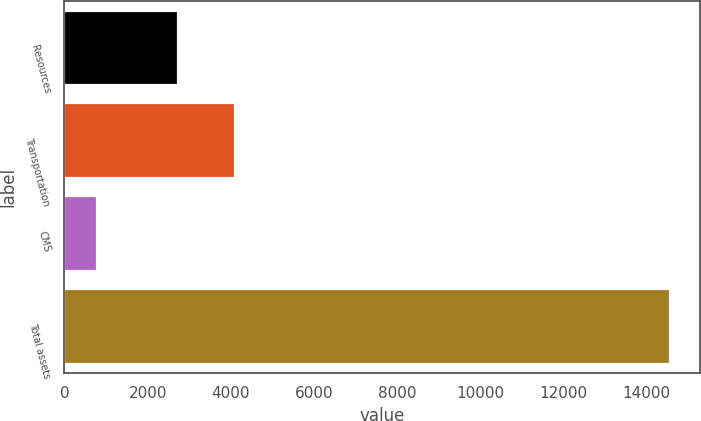Convert chart to OTSL. <chart><loc_0><loc_0><loc_500><loc_500><bar_chart><fcel>Resources<fcel>Transportation<fcel>CMS<fcel>Total assets<nl><fcel>2720.7<fcel>4098.9<fcel>772.4<fcel>14554.4<nl></chart> 